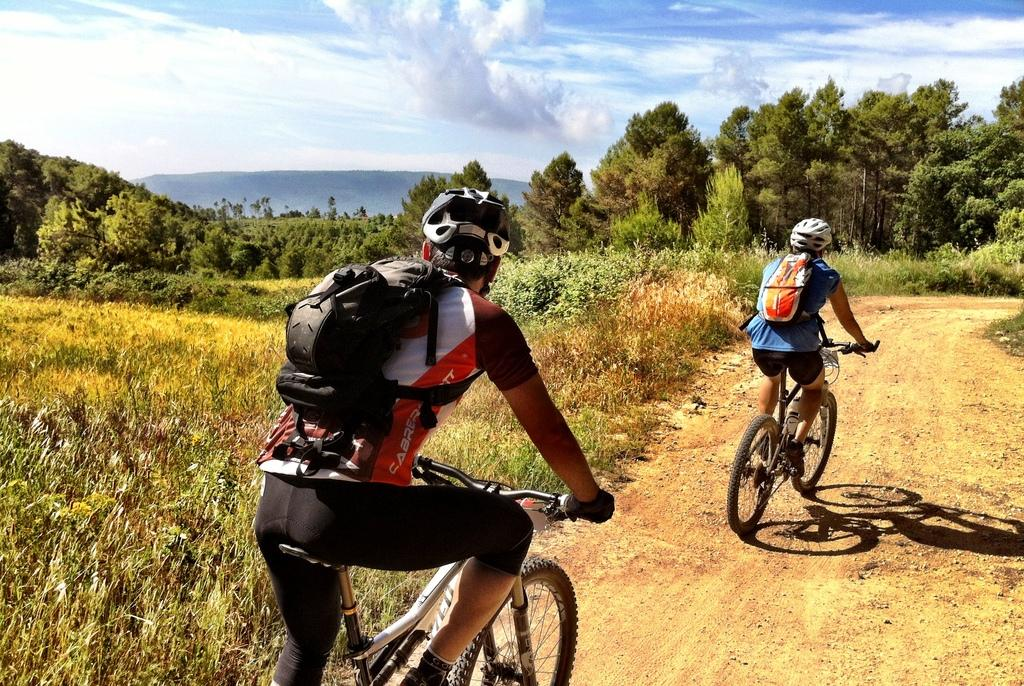How many people are in the image? There are two men in the image. What are the men doing in the image? The men are riding bicycles. What is the color and condition of the sky in the image? The sky is blue and cloudy. What type of vegetation can be seen in the image? There are trees visible in the image. What type of pie is being served on the table in the image? There is no table or pie present in the image; it features two men riding bicycles. How many letters are visible on the bicycles in the image? There is no information about letters on the bicycles in the provided facts, so we cannot determine their presence or quantity. 